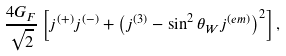<formula> <loc_0><loc_0><loc_500><loc_500>\frac { 4 G _ { F } } { \sqrt { 2 } } \left [ j ^ { ( + ) } j ^ { ( - ) } + \left ( j ^ { ( 3 ) } - \sin ^ { 2 } \theta _ { W } j ^ { ( e m ) } \right ) ^ { 2 } \right ] ,</formula> 